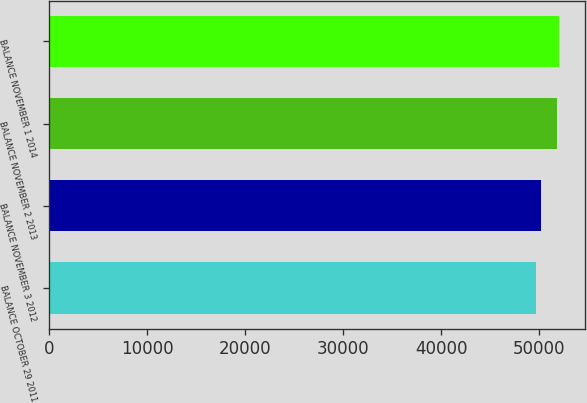Convert chart. <chart><loc_0><loc_0><loc_500><loc_500><bar_chart><fcel>BALANCE OCTOBER 29 2011<fcel>BALANCE NOVEMBER 3 2012<fcel>BALANCE NOVEMBER 2 2013<fcel>BALANCE NOVEMBER 1 2014<nl><fcel>49661<fcel>50233<fcel>51842<fcel>52062.8<nl></chart> 